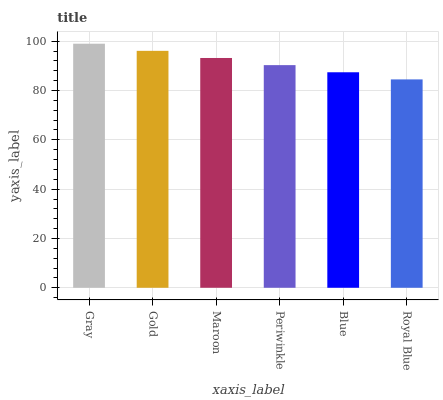Is Royal Blue the minimum?
Answer yes or no. Yes. Is Gray the maximum?
Answer yes or no. Yes. Is Gold the minimum?
Answer yes or no. No. Is Gold the maximum?
Answer yes or no. No. Is Gray greater than Gold?
Answer yes or no. Yes. Is Gold less than Gray?
Answer yes or no. Yes. Is Gold greater than Gray?
Answer yes or no. No. Is Gray less than Gold?
Answer yes or no. No. Is Maroon the high median?
Answer yes or no. Yes. Is Periwinkle the low median?
Answer yes or no. Yes. Is Blue the high median?
Answer yes or no. No. Is Blue the low median?
Answer yes or no. No. 